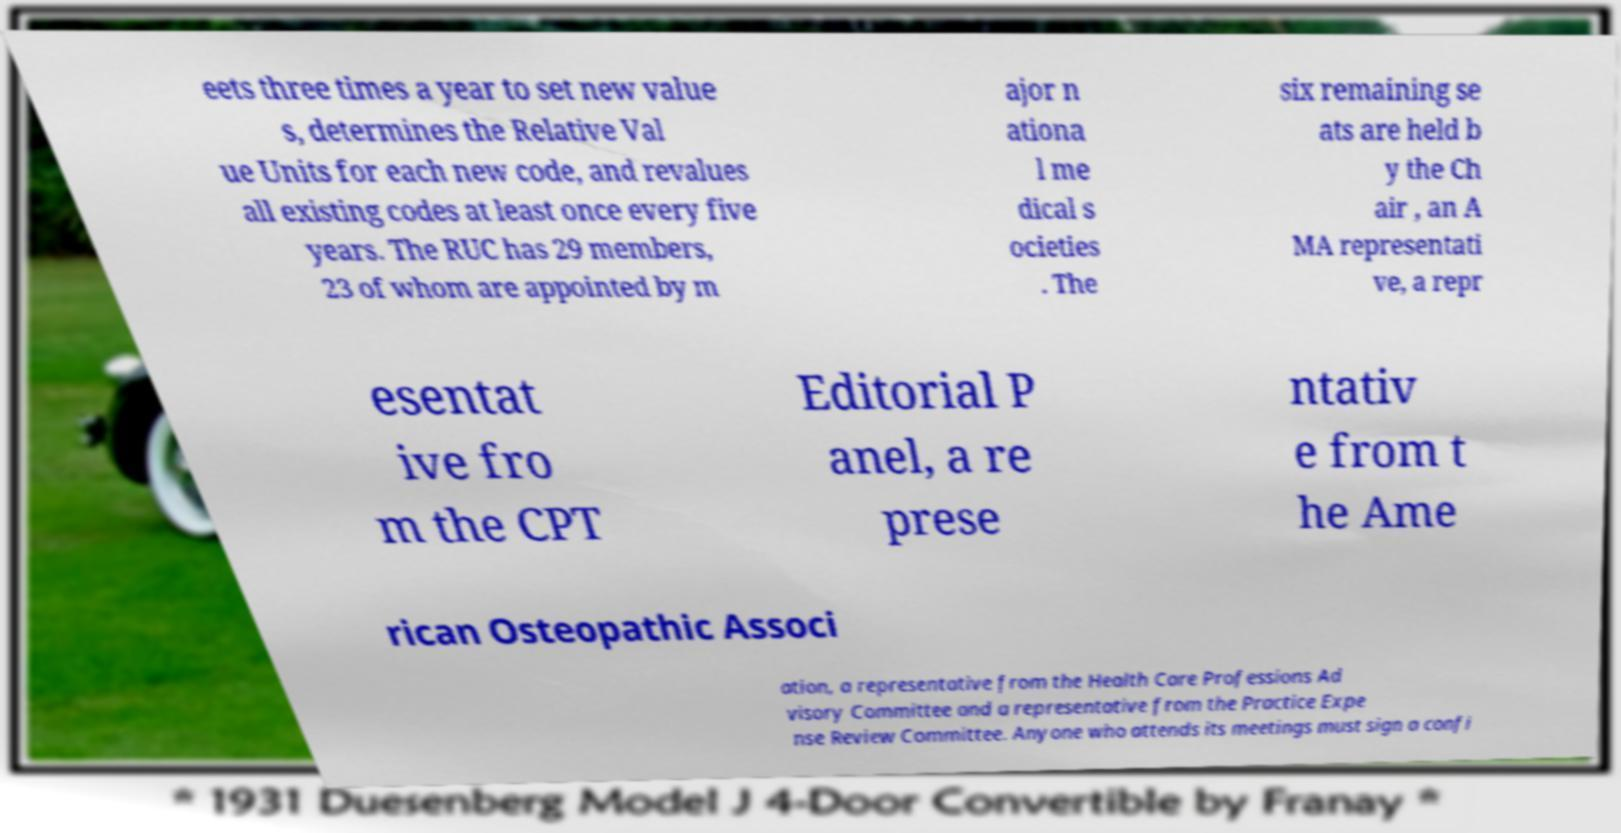Could you extract and type out the text from this image? eets three times a year to set new value s, determines the Relative Val ue Units for each new code, and revalues all existing codes at least once every five years. The RUC has 29 members, 23 of whom are appointed by m ajor n ationa l me dical s ocieties . The six remaining se ats are held b y the Ch air , an A MA representati ve, a repr esentat ive fro m the CPT Editorial P anel, a re prese ntativ e from t he Ame rican Osteopathic Associ ation, a representative from the Health Care Professions Ad visory Committee and a representative from the Practice Expe nse Review Committee. Anyone who attends its meetings must sign a confi 